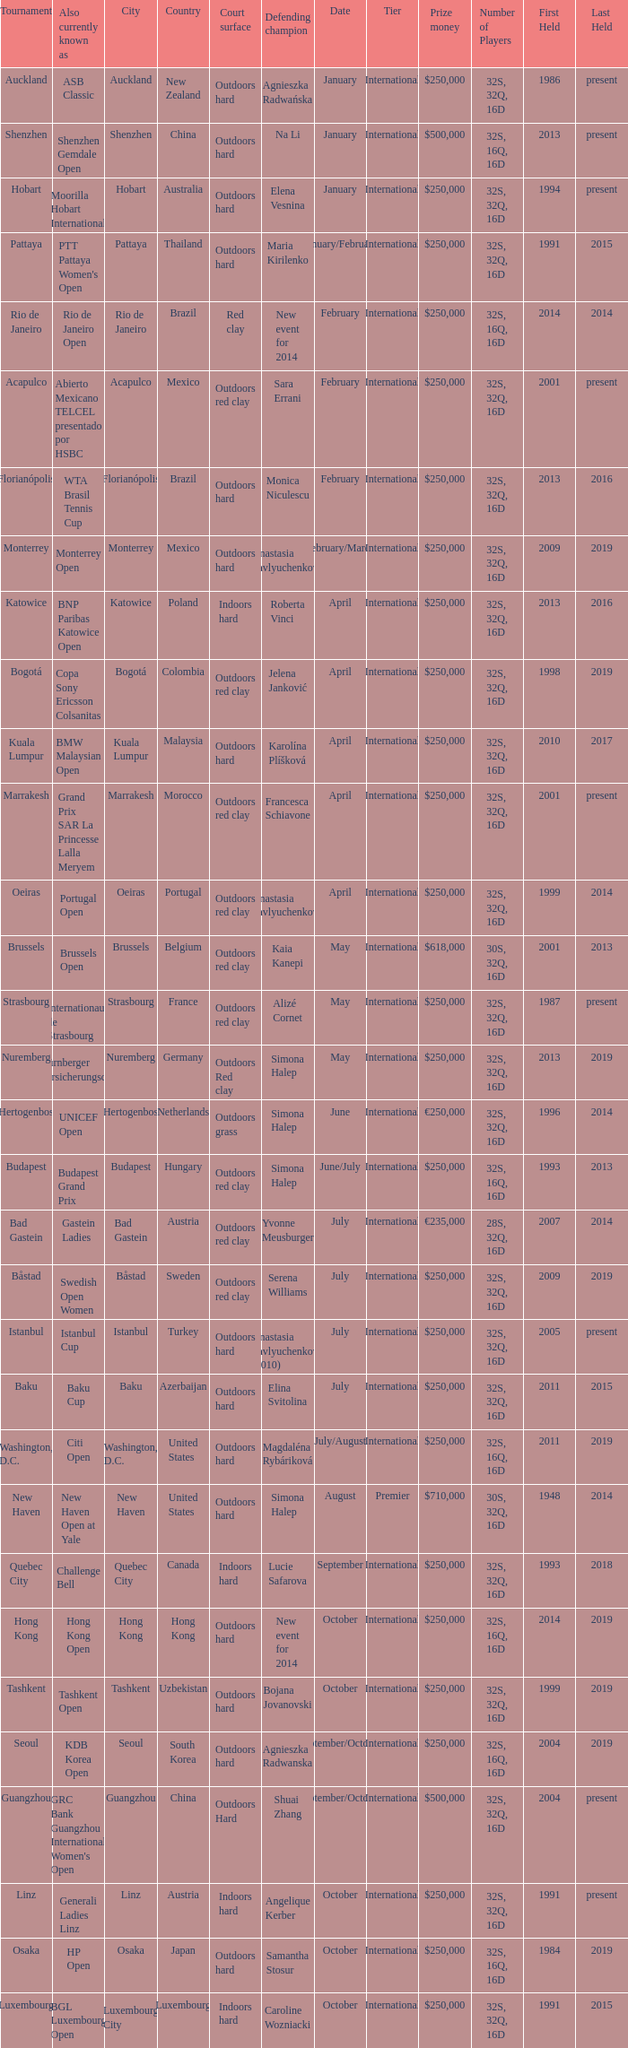What is the number of defending champions from thailand? 1.0. 